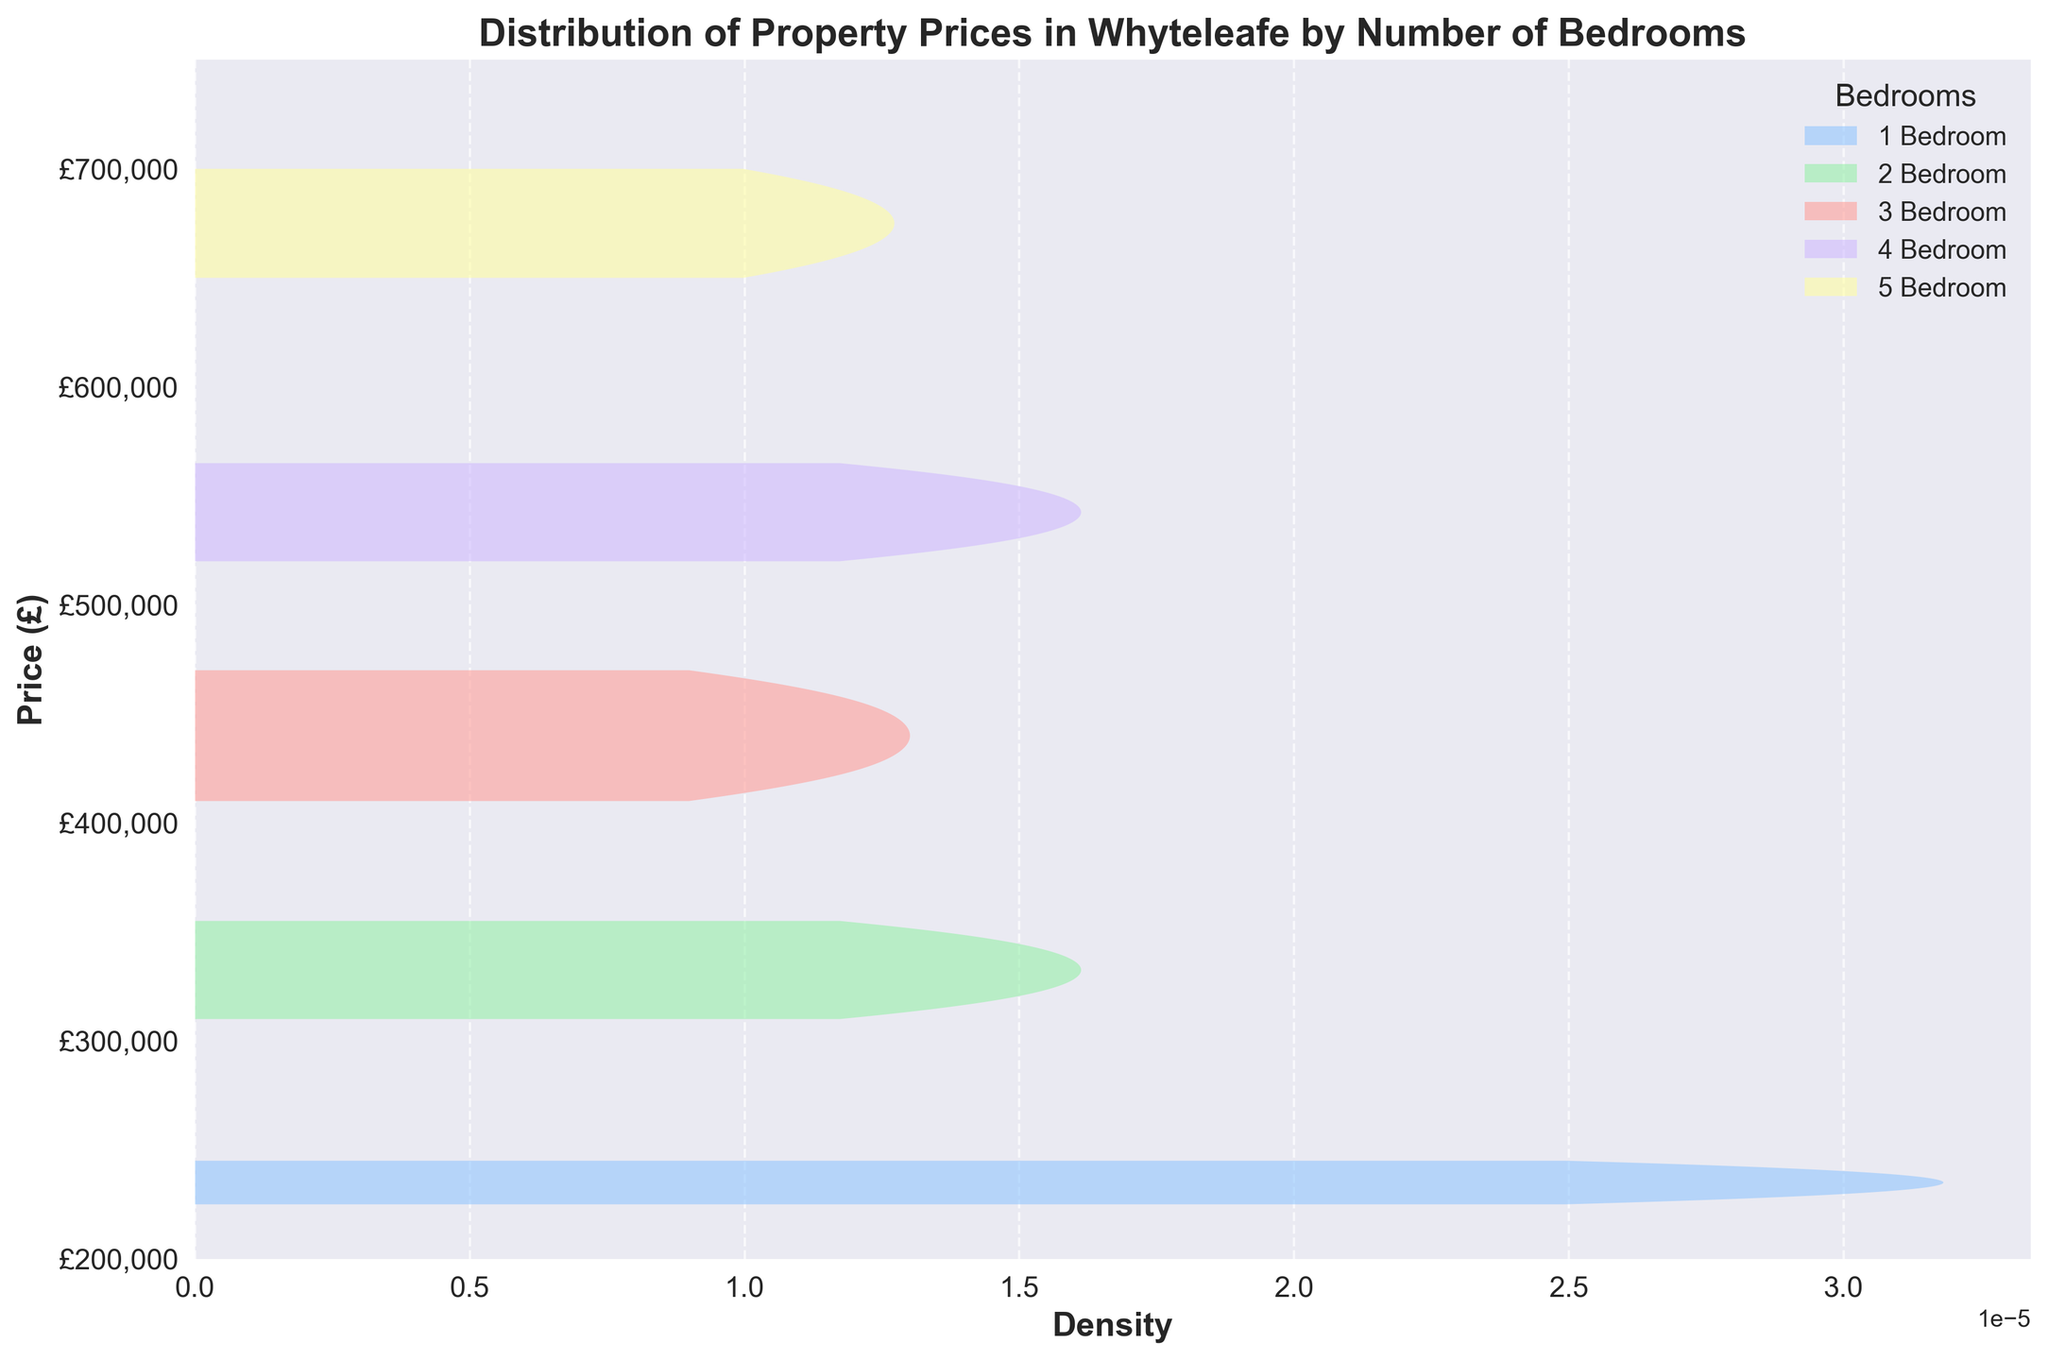What is the highest property price shown in the plot? The plot's y-axis likely indicates property prices from £200,000 to £750,000. The 5-bedroom properties have the highest prices, and the maximum price is around £700,000.
Answer: £700,000 What is the title of the plot? The plot's title is typically written at the top in a bold font. It clearly states the main theme or observation.
Answer: Distribution of Property Prices in Whyteleafe by Number of Bedrooms Among the different bedroom categories, which one has the most narrowly distributed property prices? The density plot's width and spread indicate the distribution range. The narrower the plot, the less variance in prices. The 1-bedroom category appears most narrowly distributed.
Answer: 1-Bedroom How does the price range for 4-bedroom properties compare to 3-bedroom properties? Observing the y-axis range where the densities for 3 and 4 bedrooms exist can show their price span. The 4-bedroom properties range from around £520,000 to £565,000, while 3-bedroom properties range from £410,000 to £470,000.
Answer: 4-bedroom properties generally have higher prices Which bedroom category appears to have the broadest range of property prices? The broader the density plot line along the y-axis, the wider the range of property prices it covers. The 3-bedroom properties extend over a broader range compared to others.
Answer: 3-Bedroom What is the price range for 2-bedroom properties? Checking the y-axis segment for the density line of 2-bedroom properties will indicate the minimum and maximum prices. The range is from approximately £310,000 to £355,000.
Answer: £310,000 - £355,000 Which bedroom category has the lowest starting property price? The lowest starting property price corresponds to where each density function begins on the y-axis. The 1-bedroom category appears to start around £225,000.
Answer: 1-Bedroom Is there an overlap in property prices between any bedroom categories? Checking if density curves from different categories span the same y-axis segments will reveal overlaps. For instance, 3-bedroom and 4-bedroom property prices overlap between approximately £410,000 to £470,000.
Answer: Yes, between 3 and 4-bedroom categories Does the density of 5-bedroom properties ever exceed that of 3-bedroom properties? Density peaks (x-axis height) for 5-bedroom properties need to be compared with 3-bedroom peaks. The 5-bedroom density does not exceed that of 3-bedroom properties at any point.
Answer: No What is the median property price for 4-bedroom properties? The median price splits the area under the 4-bedroom density curve into two equal halves. Estimating the middle point, the median is around £542,500.
Answer: £542,500 